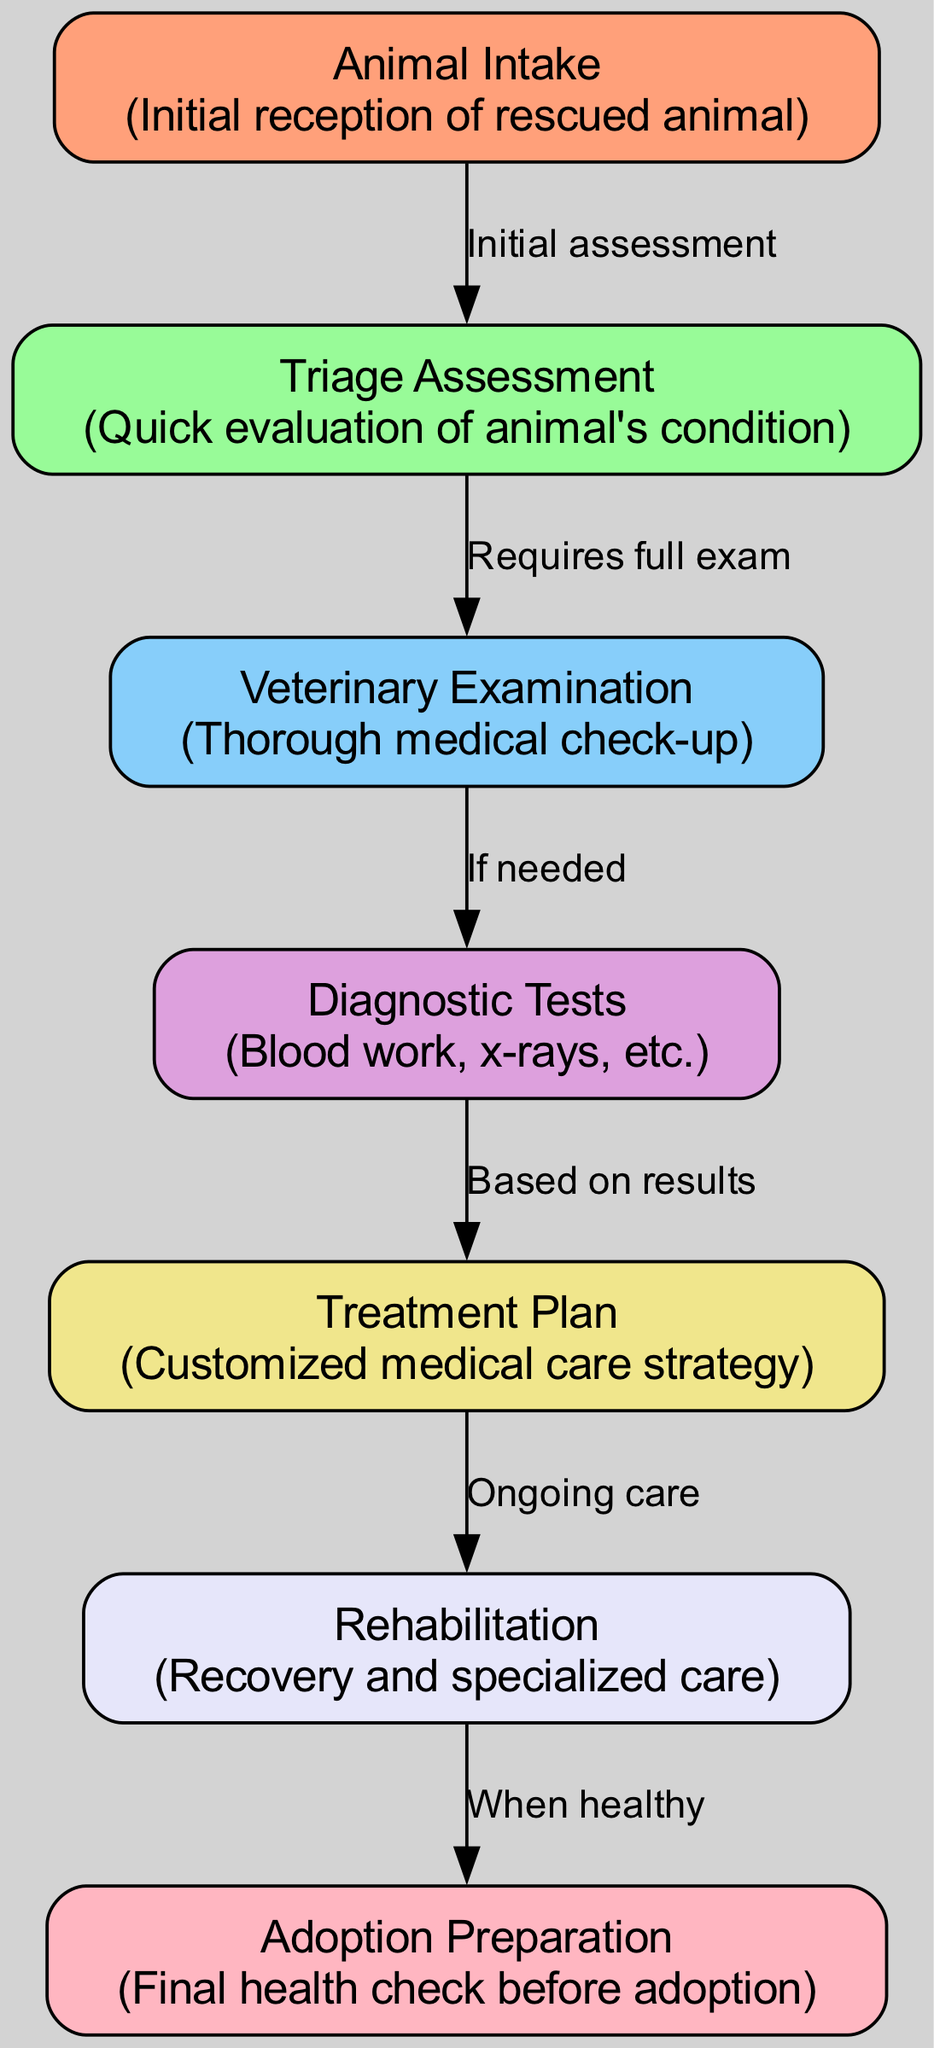What is the first stage in the animal intake process? The flowchart shows that the first node is labeled "Animal Intake," which indicates the initial reception stage for a rescued animal.
Answer: Animal Intake How many nodes are there in the diagram? By counting each unique stage listed in the diagram, there are a total of 7 nodes representing different stages of the animal intake process.
Answer: 7 What follows the Triage Assessment stage? The flowchart indicates that after the "Triage Assessment" stage, the next step is the "Veterinary Examination," as shown by the directed edge leading from triage to exam.
Answer: Veterinary Examination What kinds of tests may be conducted after examination? The diagram specifies that after the "Veterinary Examination," the next potential stage is "Diagnostic Tests," which includes procedures like blood work and x-rays.
Answer: Diagnostic Tests What is required to transition from the Veterinary Examination to the Diagnostic Tests? According to the diagram, a transition from "Veterinary Examination" to "Diagnostic Tests" occurs only "If needed," suggesting that the need for diagnostic tests arises based on the examination findings.
Answer: If needed Which stage occurs before the Adoption Preparation? The diagram clearly shows that "Rehabilitation" precedes the "Adoption Preparation" stage, indicating a necessary recovery period before animals are deemed ready for adoption.
Answer: Rehabilitation How many edges connect the nodes in the diagram? By examining the connections between the stages, there are a total of 6 edges connecting the 7 nodes in the diagram, representing the flow from one stage to the next.
Answer: 6 What is the purpose of the Treatment Plan? The flowchart indicates that the "Treatment Plan" stage involves creating a customized medical care strategy for the animal based on earlier assessments and the results of diagnostic tests.
Answer: Customized medical care strategy What is the condition for an animal to move from Rehabilitation to Adoption Preparation? The diagram states that the transition to "Adoption Preparation" occurs "When healthy," indicating that only animals that have recovered sufficiently can progress to this stage.
Answer: When healthy 